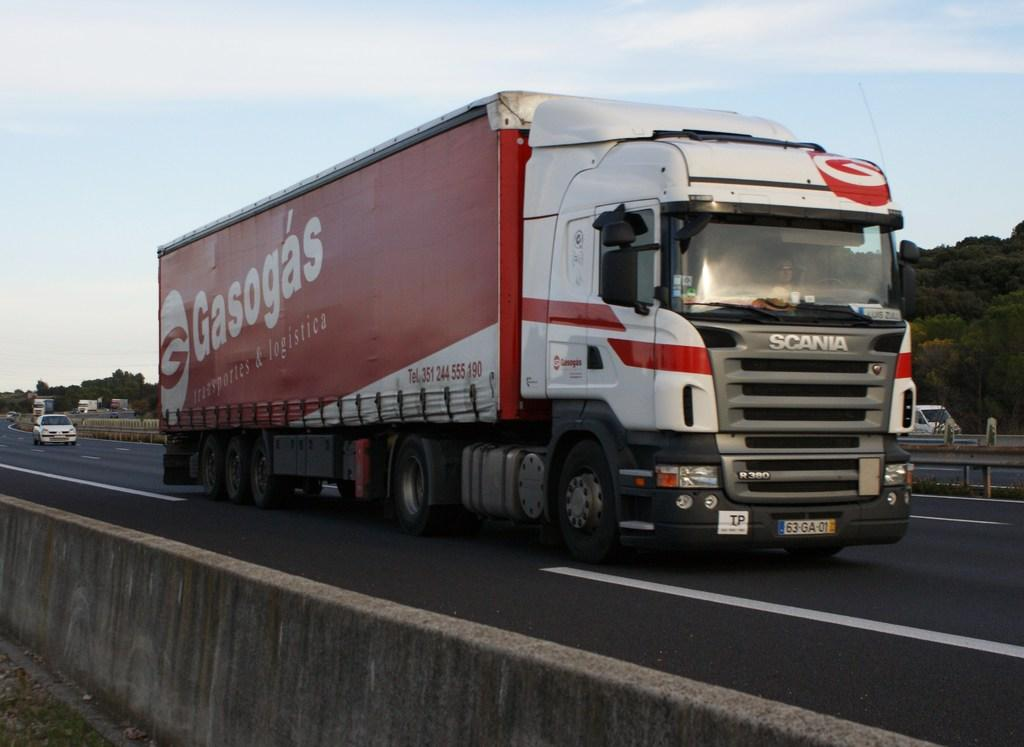What can be seen on the road in the image? There are vehicles on the road in the image. What is visible in the background of the image? There is a wall, trees, and a fence in the background of the image. What is visible at the top of the image? The sky is visible at the top of the image. Can you tell me how many bells are hanging from the wall in the image? There are no bells present in the image; the wall is in the background, and the focus is on the vehicles on the road. What type of thing is being approved in the image? There is no approval process or decision being made in the image; it simply shows vehicles on a road with a background of a wall, trees, and a fence. 